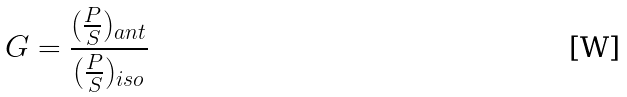<formula> <loc_0><loc_0><loc_500><loc_500>G = \frac { ( \frac { P } { S } ) _ { a n t } } { ( \frac { P } { S } ) _ { i s o } }</formula> 